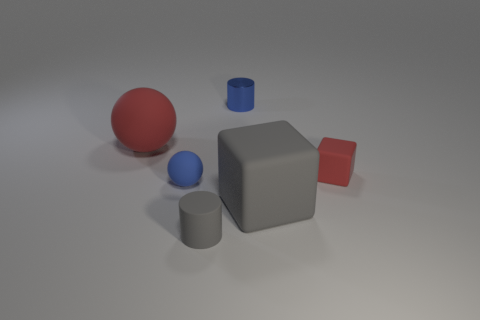Add 3 tiny yellow metallic objects. How many objects exist? 9 Subtract 0 yellow cylinders. How many objects are left? 6 Subtract all small spheres. Subtract all tiny blue matte balls. How many objects are left? 4 Add 2 large red matte spheres. How many large red matte spheres are left? 3 Add 5 tiny matte balls. How many tiny matte balls exist? 6 